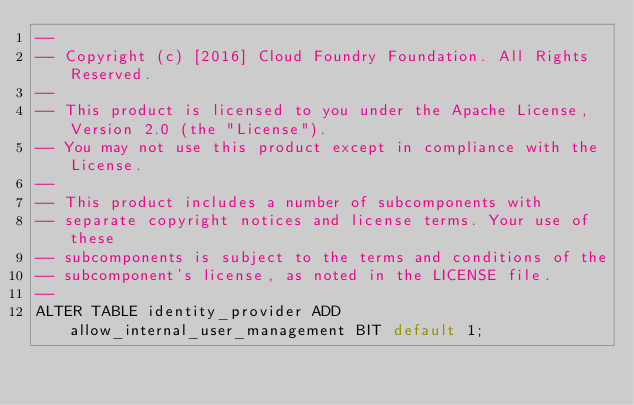Convert code to text. <code><loc_0><loc_0><loc_500><loc_500><_SQL_>--
-- Copyright (c) [2016] Cloud Foundry Foundation. All Rights Reserved.
--
-- This product is licensed to you under the Apache License, Version 2.0 (the "License").
-- You may not use this product except in compliance with the License.
--
-- This product includes a number of subcomponents with
-- separate copyright notices and license terms. Your use of these
-- subcomponents is subject to the terms and conditions of the
-- subcomponent's license, as noted in the LICENSE file.
--
ALTER TABLE identity_provider ADD allow_internal_user_management BIT default 1;
</code> 